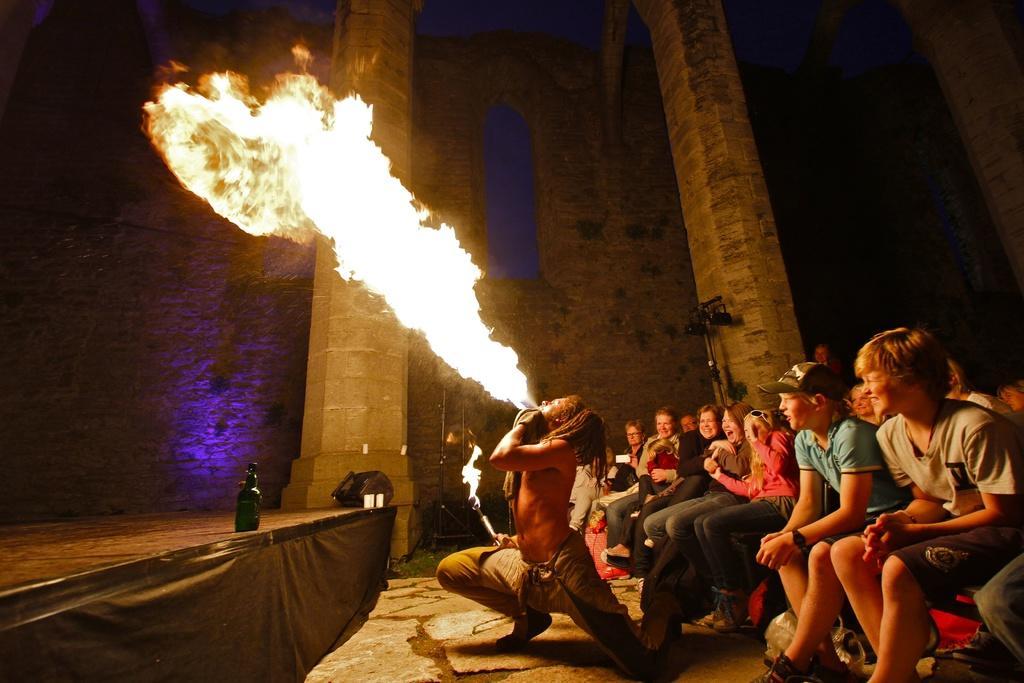How would you summarize this image in a sentence or two? In this image we can see a person blowing fire from the mouth. Near to the person many people are sitting. One person is wearing cap and a watch. There is a platform. On that there is a bottle. In the back there are pillars. Near to that there is an object. And there are walls in the back. 